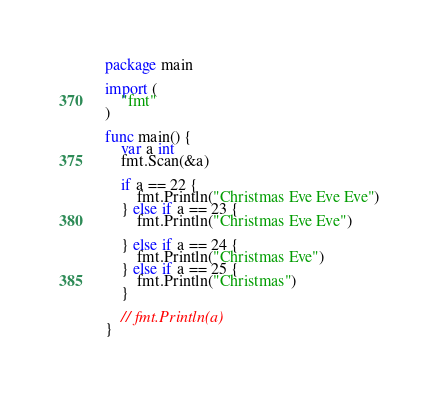Convert code to text. <code><loc_0><loc_0><loc_500><loc_500><_Go_>package main

import (
	"fmt"
)

func main() {
	var a int
	fmt.Scan(&a)

	if a == 22 {
		fmt.Println("Christmas Eve Eve Eve")
	} else if a == 23 {
		fmt.Println("Christmas Eve Eve")

	} else if a == 24 {
		fmt.Println("Christmas Eve")
	} else if a == 25 {
		fmt.Println("Christmas")
	}

	// fmt.Println(a)
}</code> 